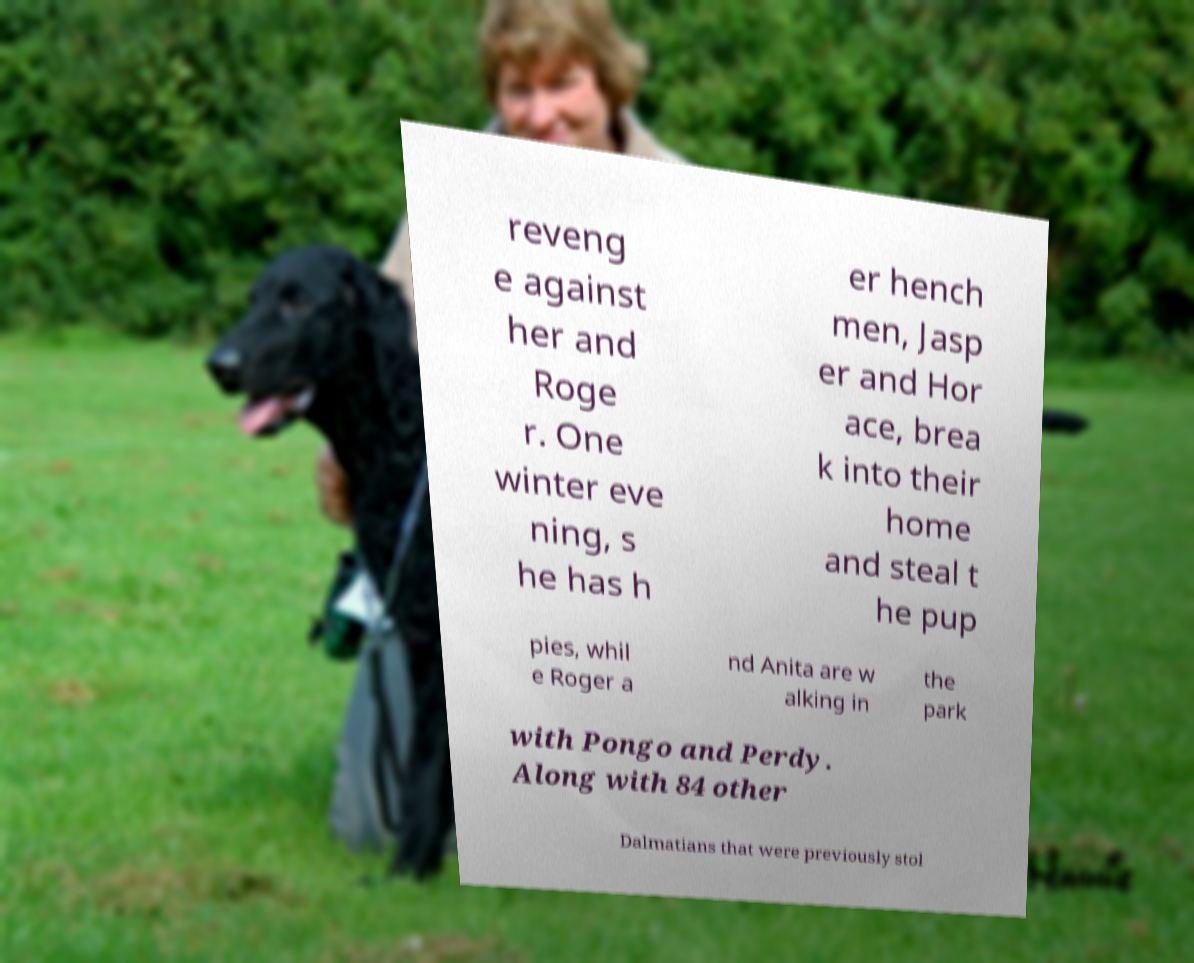Could you extract and type out the text from this image? reveng e against her and Roge r. One winter eve ning, s he has h er hench men, Jasp er and Hor ace, brea k into their home and steal t he pup pies, whil e Roger a nd Anita are w alking in the park with Pongo and Perdy. Along with 84 other Dalmatians that were previously stol 